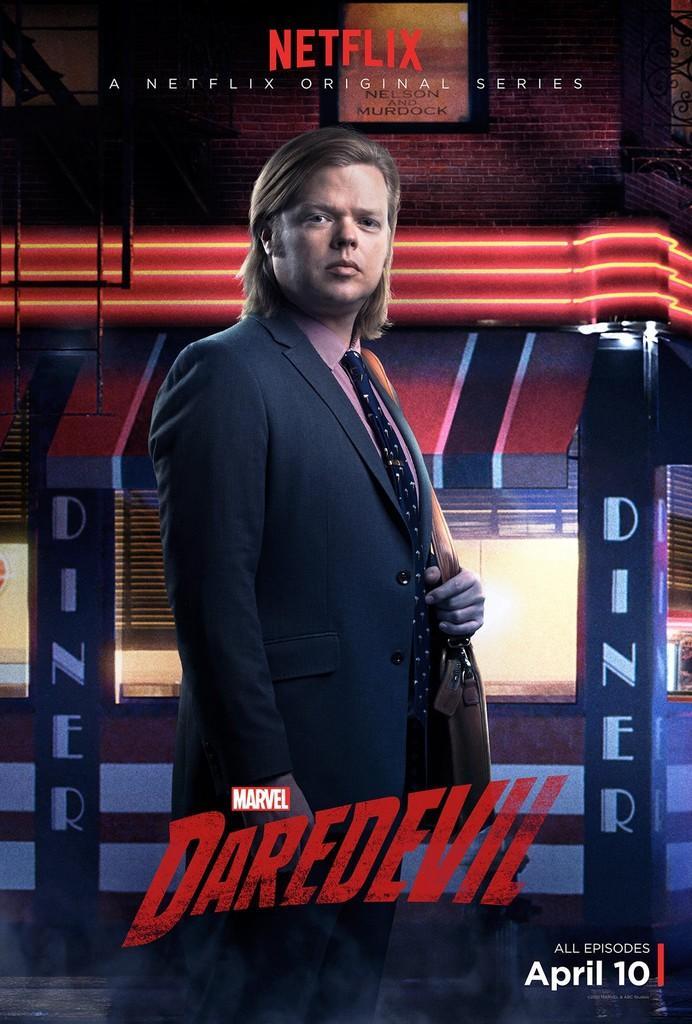Could you give a brief overview of what you see in this image? In this image, we can see an advertisement contains some text. There is a person wearing clothes in front of the building. 